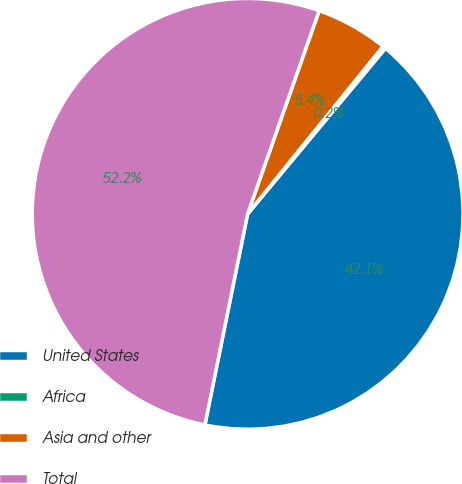Convert chart to OTSL. <chart><loc_0><loc_0><loc_500><loc_500><pie_chart><fcel>United States<fcel>Africa<fcel>Asia and other<fcel>Total<nl><fcel>42.13%<fcel>0.23%<fcel>5.43%<fcel>52.21%<nl></chart> 